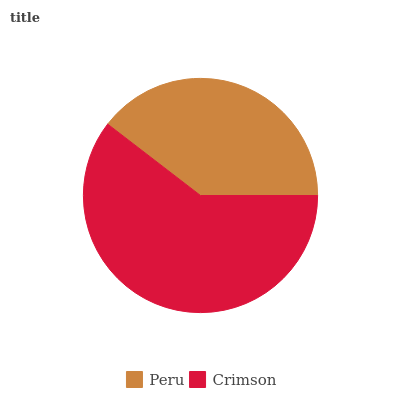Is Peru the minimum?
Answer yes or no. Yes. Is Crimson the maximum?
Answer yes or no. Yes. Is Crimson the minimum?
Answer yes or no. No. Is Crimson greater than Peru?
Answer yes or no. Yes. Is Peru less than Crimson?
Answer yes or no. Yes. Is Peru greater than Crimson?
Answer yes or no. No. Is Crimson less than Peru?
Answer yes or no. No. Is Crimson the high median?
Answer yes or no. Yes. Is Peru the low median?
Answer yes or no. Yes. Is Peru the high median?
Answer yes or no. No. Is Crimson the low median?
Answer yes or no. No. 